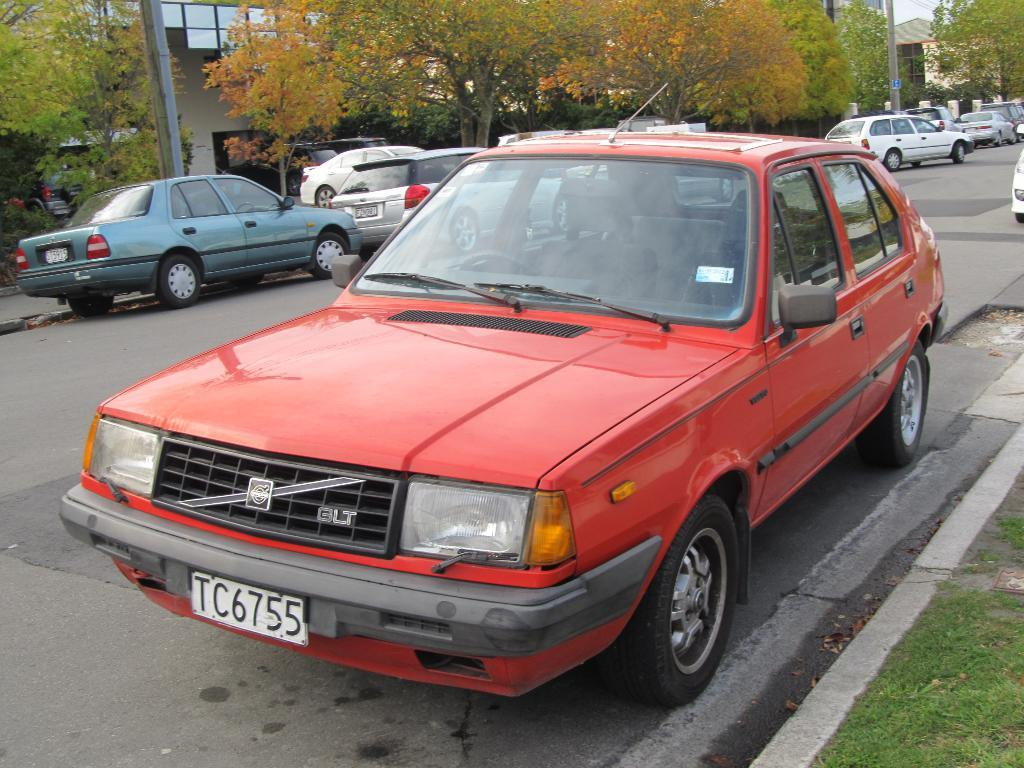What is happening on the road in the image? There are vehicles on the road in the image. What type of natural environment is visible in the image? There is grass and trees visible in the image. What are the tall, thin structures in the image? There are poles in the image. What can be seen in the distance in the image? There are buildings in the background of the image. What type of cream is being spread on the kite in the image? There is no kite or cream present in the image. What statement is being made by the vehicles on the road in the image? The image does not convey a statement; it simply shows vehicles on the road. 